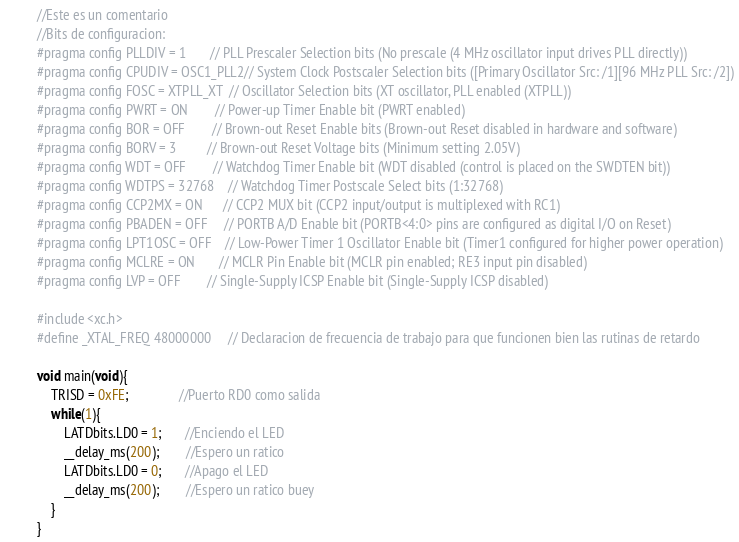<code> <loc_0><loc_0><loc_500><loc_500><_C_>//Este es un comentario
//Bits de configuracion:
#pragma config PLLDIV = 1       // PLL Prescaler Selection bits (No prescale (4 MHz oscillator input drives PLL directly))
#pragma config CPUDIV = OSC1_PLL2// System Clock Postscaler Selection bits ([Primary Oscillator Src: /1][96 MHz PLL Src: /2])
#pragma config FOSC = XTPLL_XT  // Oscillator Selection bits (XT oscillator, PLL enabled (XTPLL))
#pragma config PWRT = ON        // Power-up Timer Enable bit (PWRT enabled)
#pragma config BOR = OFF        // Brown-out Reset Enable bits (Brown-out Reset disabled in hardware and software)
#pragma config BORV = 3         // Brown-out Reset Voltage bits (Minimum setting 2.05V)
#pragma config WDT = OFF        // Watchdog Timer Enable bit (WDT disabled (control is placed on the SWDTEN bit))
#pragma config WDTPS = 32768    // Watchdog Timer Postscale Select bits (1:32768)
#pragma config CCP2MX = ON      // CCP2 MUX bit (CCP2 input/output is multiplexed with RC1)
#pragma config PBADEN = OFF     // PORTB A/D Enable bit (PORTB<4:0> pins are configured as digital I/O on Reset)
#pragma config LPT1OSC = OFF    // Low-Power Timer 1 Oscillator Enable bit (Timer1 configured for higher power operation)
#pragma config MCLRE = ON       // MCLR Pin Enable bit (MCLR pin enabled; RE3 input pin disabled)
#pragma config LVP = OFF        // Single-Supply ICSP Enable bit (Single-Supply ICSP disabled)

#include <xc.h>
#define _XTAL_FREQ 48000000     // Declaracion de frecuencia de trabajo para que funcionen bien las rutinas de retardo

void main(void){
    TRISD = 0xFE;               //Puerto RD0 como salida
    while(1){
        LATDbits.LD0 = 1;       //Enciendo el LED
        __delay_ms(200);        //Espero un ratico
        LATDbits.LD0 = 0;       //Apago el LED
        __delay_ms(200);        //Espero un ratico buey
    }
}</code> 